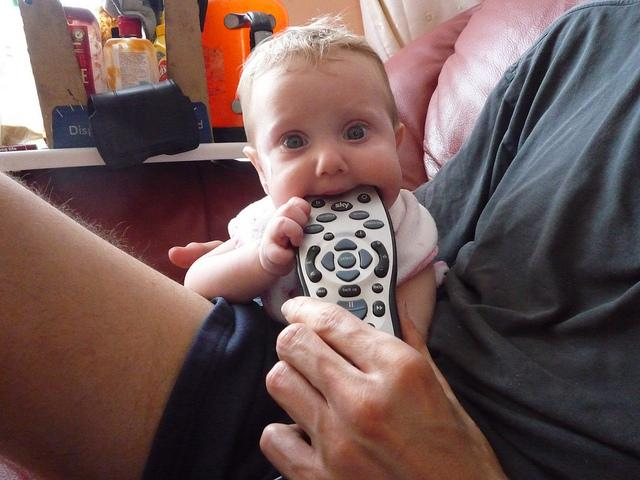What is the baby attempting to eat? Please explain your reasoning. remote control. The baby has a remote control in her mouth. she is chewing on it. 